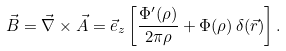<formula> <loc_0><loc_0><loc_500><loc_500>\vec { B } = \vec { \nabla } \times \vec { A } = \vec { e } _ { z } \left [ \frac { \Phi ^ { \prime } ( \rho ) } { 2 \pi \rho } + \Phi ( \rho ) \, \delta ( \vec { r } ) \right ] .</formula> 